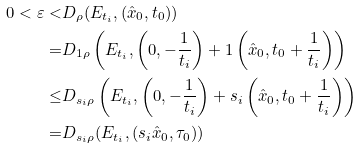Convert formula to latex. <formula><loc_0><loc_0><loc_500><loc_500>0 < \varepsilon < & D _ { \rho } ( E _ { t _ { i } } , ( \hat { x } _ { 0 } , t _ { 0 } ) ) \\ = & D _ { 1 \rho } \left ( E _ { t _ { i } } , \left ( 0 , - \frac { 1 } { t _ { i } } \right ) + 1 \left ( \hat { x } _ { 0 } , t _ { 0 } + \frac { 1 } { t _ { i } } \right ) \right ) \\ \leq & D _ { s _ { i } \rho } \left ( E _ { t _ { i } } , \left ( 0 , - \frac { 1 } { t _ { i } } \right ) + s _ { i } \left ( \hat { x } _ { 0 } , t _ { 0 } + \frac { 1 } { t _ { i } } \right ) \right ) \\ = & D _ { s _ { i } \rho } ( E _ { t _ { i } } , ( s _ { i } \hat { x } _ { 0 } , \tau _ { 0 } ) )</formula> 